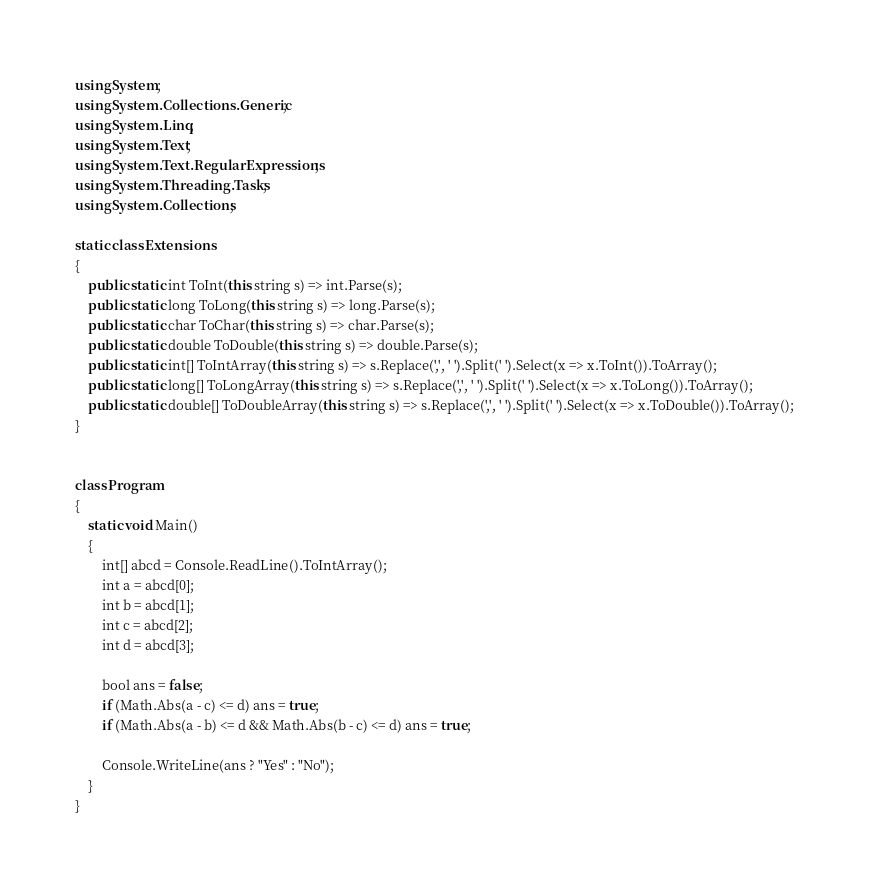Convert code to text. <code><loc_0><loc_0><loc_500><loc_500><_C#_>using System;
using System.Collections.Generic;
using System.Linq;
using System.Text;
using System.Text.RegularExpressions;
using System.Threading.Tasks;
using System.Collections;

static class Extensions
{
    public static int ToInt(this string s) => int.Parse(s);
    public static long ToLong(this string s) => long.Parse(s);
    public static char ToChar(this string s) => char.Parse(s);
    public static double ToDouble(this string s) => double.Parse(s);
    public static int[] ToIntArray(this string s) => s.Replace(',', ' ').Split(' ').Select(x => x.ToInt()).ToArray();
    public static long[] ToLongArray(this string s) => s.Replace(',', ' ').Split(' ').Select(x => x.ToLong()).ToArray();
    public static double[] ToDoubleArray(this string s) => s.Replace(',', ' ').Split(' ').Select(x => x.ToDouble()).ToArray();
}


class Program
{
    static void Main()
    {
        int[] abcd = Console.ReadLine().ToIntArray();
        int a = abcd[0];
        int b = abcd[1];
        int c = abcd[2];
        int d = abcd[3];

        bool ans = false;
        if (Math.Abs(a - c) <= d) ans = true;
        if (Math.Abs(a - b) <= d && Math.Abs(b - c) <= d) ans = true;

        Console.WriteLine(ans ? "Yes" : "No");
    }
}
</code> 